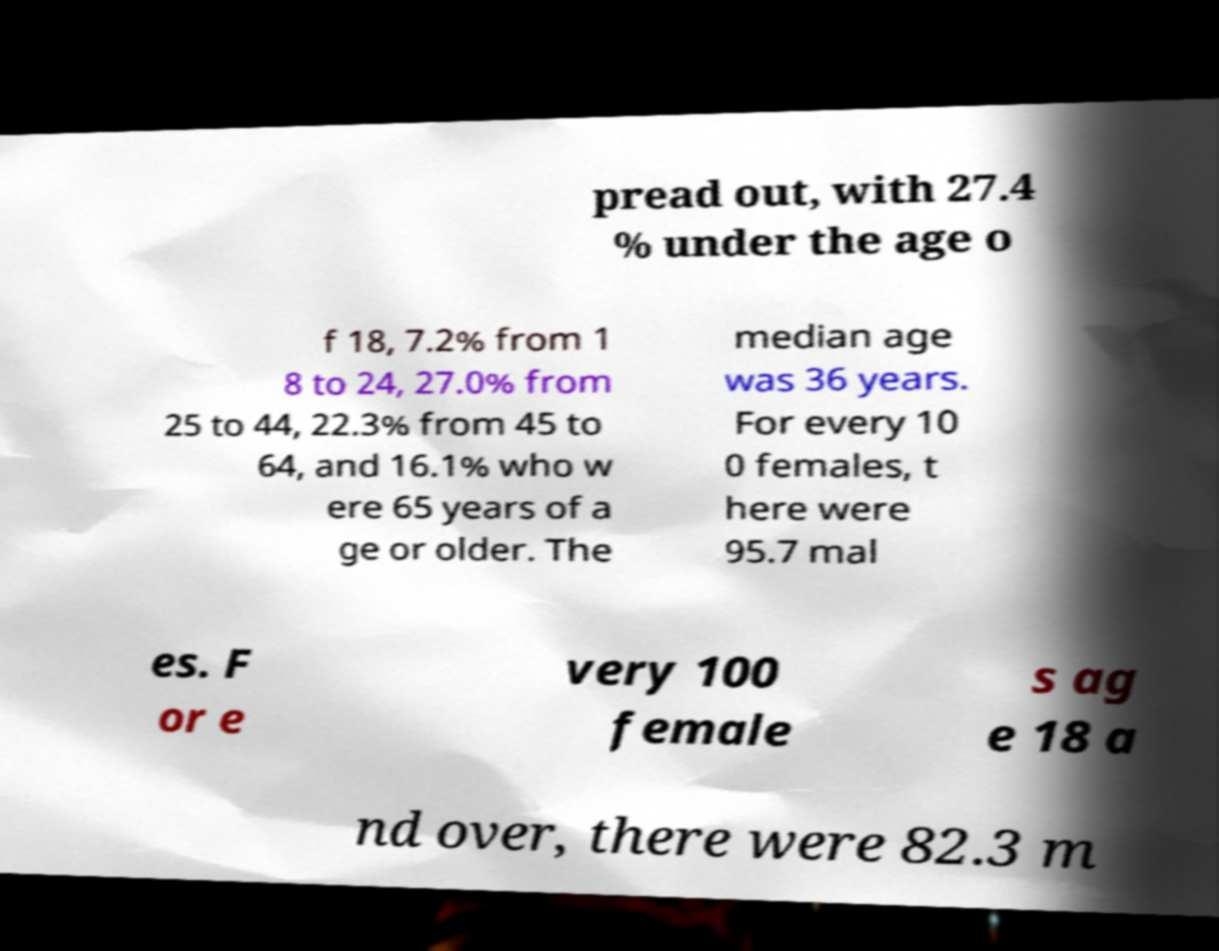Can you read and provide the text displayed in the image?This photo seems to have some interesting text. Can you extract and type it out for me? pread out, with 27.4 % under the age o f 18, 7.2% from 1 8 to 24, 27.0% from 25 to 44, 22.3% from 45 to 64, and 16.1% who w ere 65 years of a ge or older. The median age was 36 years. For every 10 0 females, t here were 95.7 mal es. F or e very 100 female s ag e 18 a nd over, there were 82.3 m 